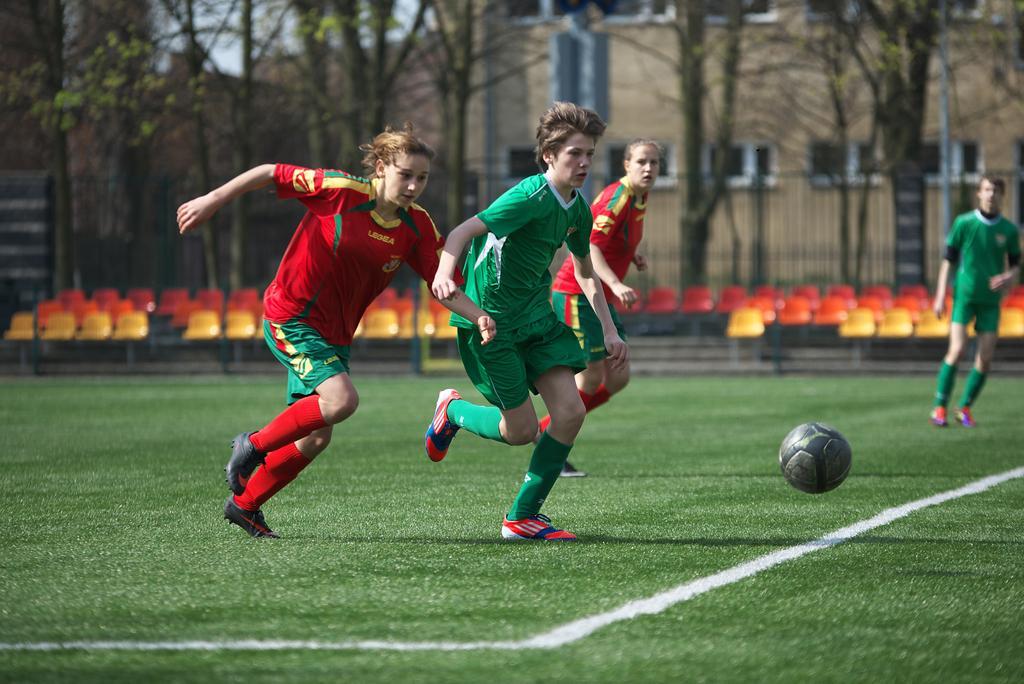Describe this image in one or two sentences. This picture is clicked outside. On the left we can see the group of persons wearing t-shirts and running on the ground. On the right we can see the ball is in the air. On the right corner there is another person wearing green color t-shirt and seems to be standing on the ground, the ground is covered with the green grass. In the background we can see the buildings, sky, trees and the chairs. 